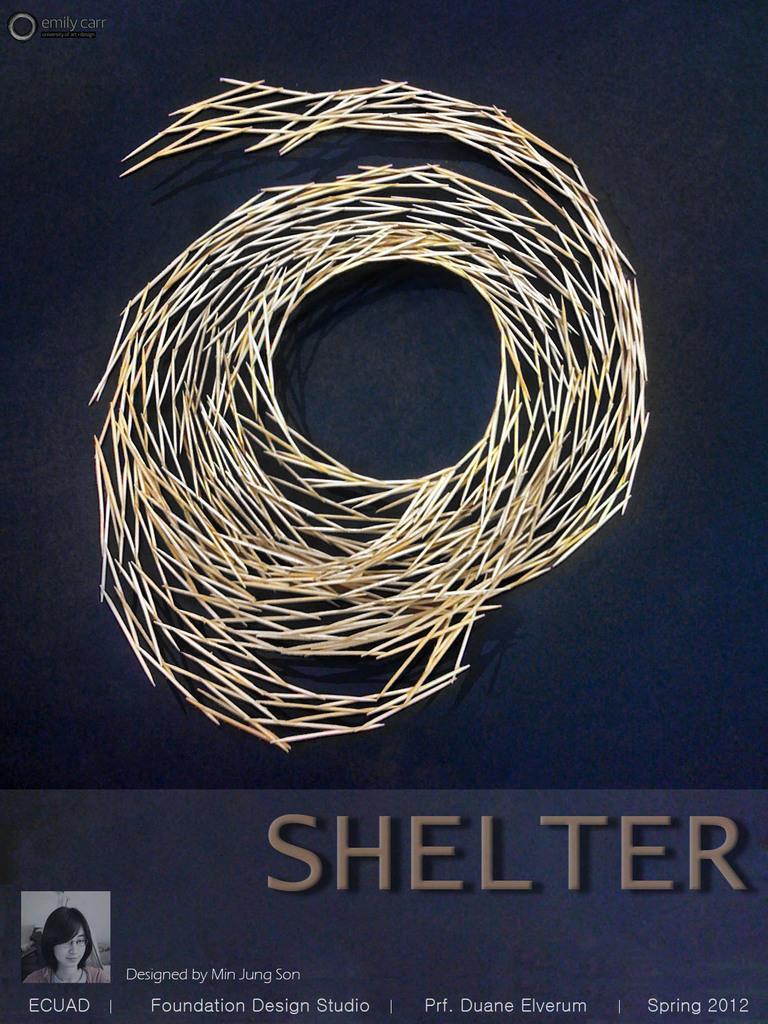Could you give a brief overview of what you see in this image? In this picture I can observe a symbol which is made up of toothpicks. The symbol is in cream color. The background is in black color. On the bottom of the picture I can observe some text. 